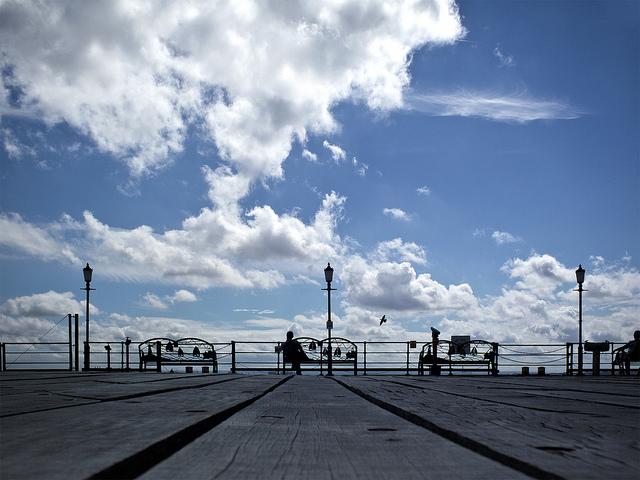How many light post?
Keep it brief. 3. What land feature is in the background?
Give a very brief answer. Ocean. Is this a peaceful day?
Answer briefly. Yes. What color are the lines?
Keep it brief. Black. What is most likely under the boards?
Short answer required. Water. Are there clouds in the sky?
Short answer required. Yes. Is the person in motion?
Short answer required. No. Is it a train station?
Write a very short answer. No. How many people are sitting in benches?
Quick response, please. 2. What time of day was this taken?
Quick response, please. Afternoon. Is there  a train?
Quick response, please. No. 